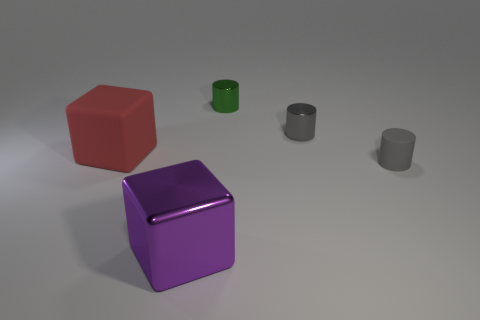How big is the thing that is both left of the green shiny thing and right of the red matte thing?
Your answer should be compact. Large. Is the number of large metal blocks behind the small green metallic cylinder less than the number of tiny yellow rubber cylinders?
Offer a terse response. No. Are the purple block and the red block made of the same material?
Your answer should be very brief. No. How many objects are either tiny matte cylinders or shiny cylinders?
Your response must be concise. 3. How many small cylinders are the same material as the big red block?
Your answer should be compact. 1. What size is the metal object that is the same shape as the red matte object?
Provide a succinct answer. Large. Are there any blocks on the right side of the red matte thing?
Your response must be concise. Yes. What is the material of the big red thing?
Offer a terse response. Rubber. There is a small metallic cylinder that is right of the tiny green shiny cylinder; is its color the same as the small matte object?
Your response must be concise. Yes. Is there any other thing that has the same shape as the green metallic object?
Your answer should be compact. Yes. 